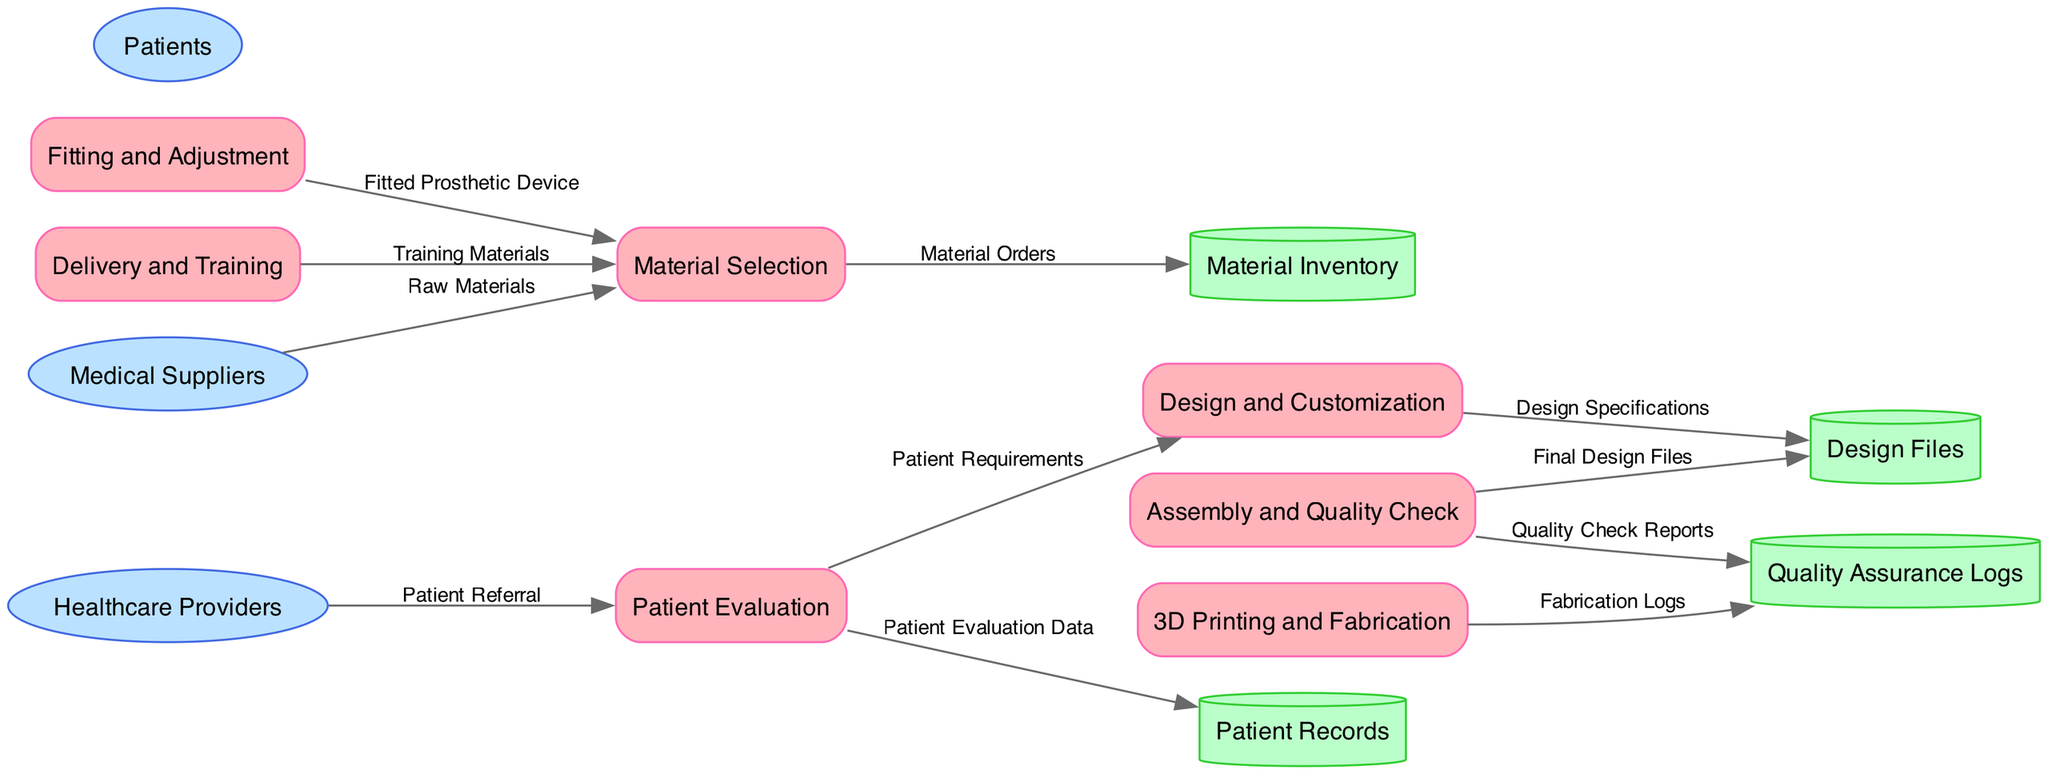What is the first process in the workflow? The first process listed in the diagram is "Patient Evaluation". This is evident because it is the first item available under the "processes" section, indicating it is the starting point of the workflow.
Answer: Patient Evaluation How many data stores are present in the diagram? The diagram lists four data stores within the "data_stores" section: Patient Records, Design Files, Material Inventory, and Quality Assurance Logs. Thus, counting these gives us a total of four data stores.
Answer: 4 What data flows from the "Assembly and Quality Check" process? The data that flows from the "Assembly and Quality Check" process consists of two items: "Quality Check Reports" which goes to the Quality Assurance Logs, and "Final Design Files" which goes back to the Design Files. This indicates that the process outputs two distinct data flows.
Answer: Quality Check Reports, Final Design Files Which external entity supplies raw materials? The external entity that supplies raw materials is "Medical Suppliers," as indicated in the diagram by the data flow labeled "Raw Materials" flowing from the Medical Suppliers to the Patients.
Answer: Medical Suppliers What is the last step before the device is delivered to the patient? The last step before delivering the device, according to the workflow, is "Fitting and Adjustment." This process happens right before the final delivery and training, ensuring the device is appropriately fitted to the patient.
Answer: Fitting and Adjustment How does "Material Selection" contribute to the design process? "Material Selection" contributes to the design process by choosing the materials needed for the prosthetic device. The data flow indicates that the selected materials, labelled as "Material Orders", directly support the subsequent manufacturing steps. This linking demonstrates the relevance of material selection to the overall design and development of the prosthetic device.
Answer: Supports design with selected materials Which process receives patient requirements from the initial evaluation? The process that receives patient requirements from the initial evaluation is "Design and Customization." According to the data flow depicted in the diagram, the "Patient Requirements" generated in the first process are directed to the second process for personalized design creation.
Answer: Design and Customization What type of documentation is stored in the Quality Assurance Logs? The type of documentation stored in the Quality Assurance Logs consists of "Quality Check Reports." This is evident from the data flow going from the Assembly and Quality Check process to the Quality Assurance Logs, indicating that performance reports and checks conducted during the assembly phase are documented there.
Answer: Quality Check Reports 